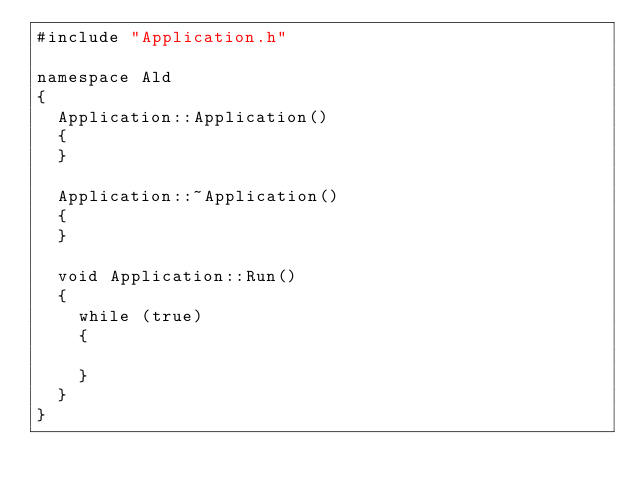Convert code to text. <code><loc_0><loc_0><loc_500><loc_500><_C++_>#include "Application.h"

namespace Ald
{
	Application::Application()
	{
	}

	Application::~Application()
	{
	}

	void Application::Run()
	{
		while (true)
		{
			
		}
	}
}
</code> 